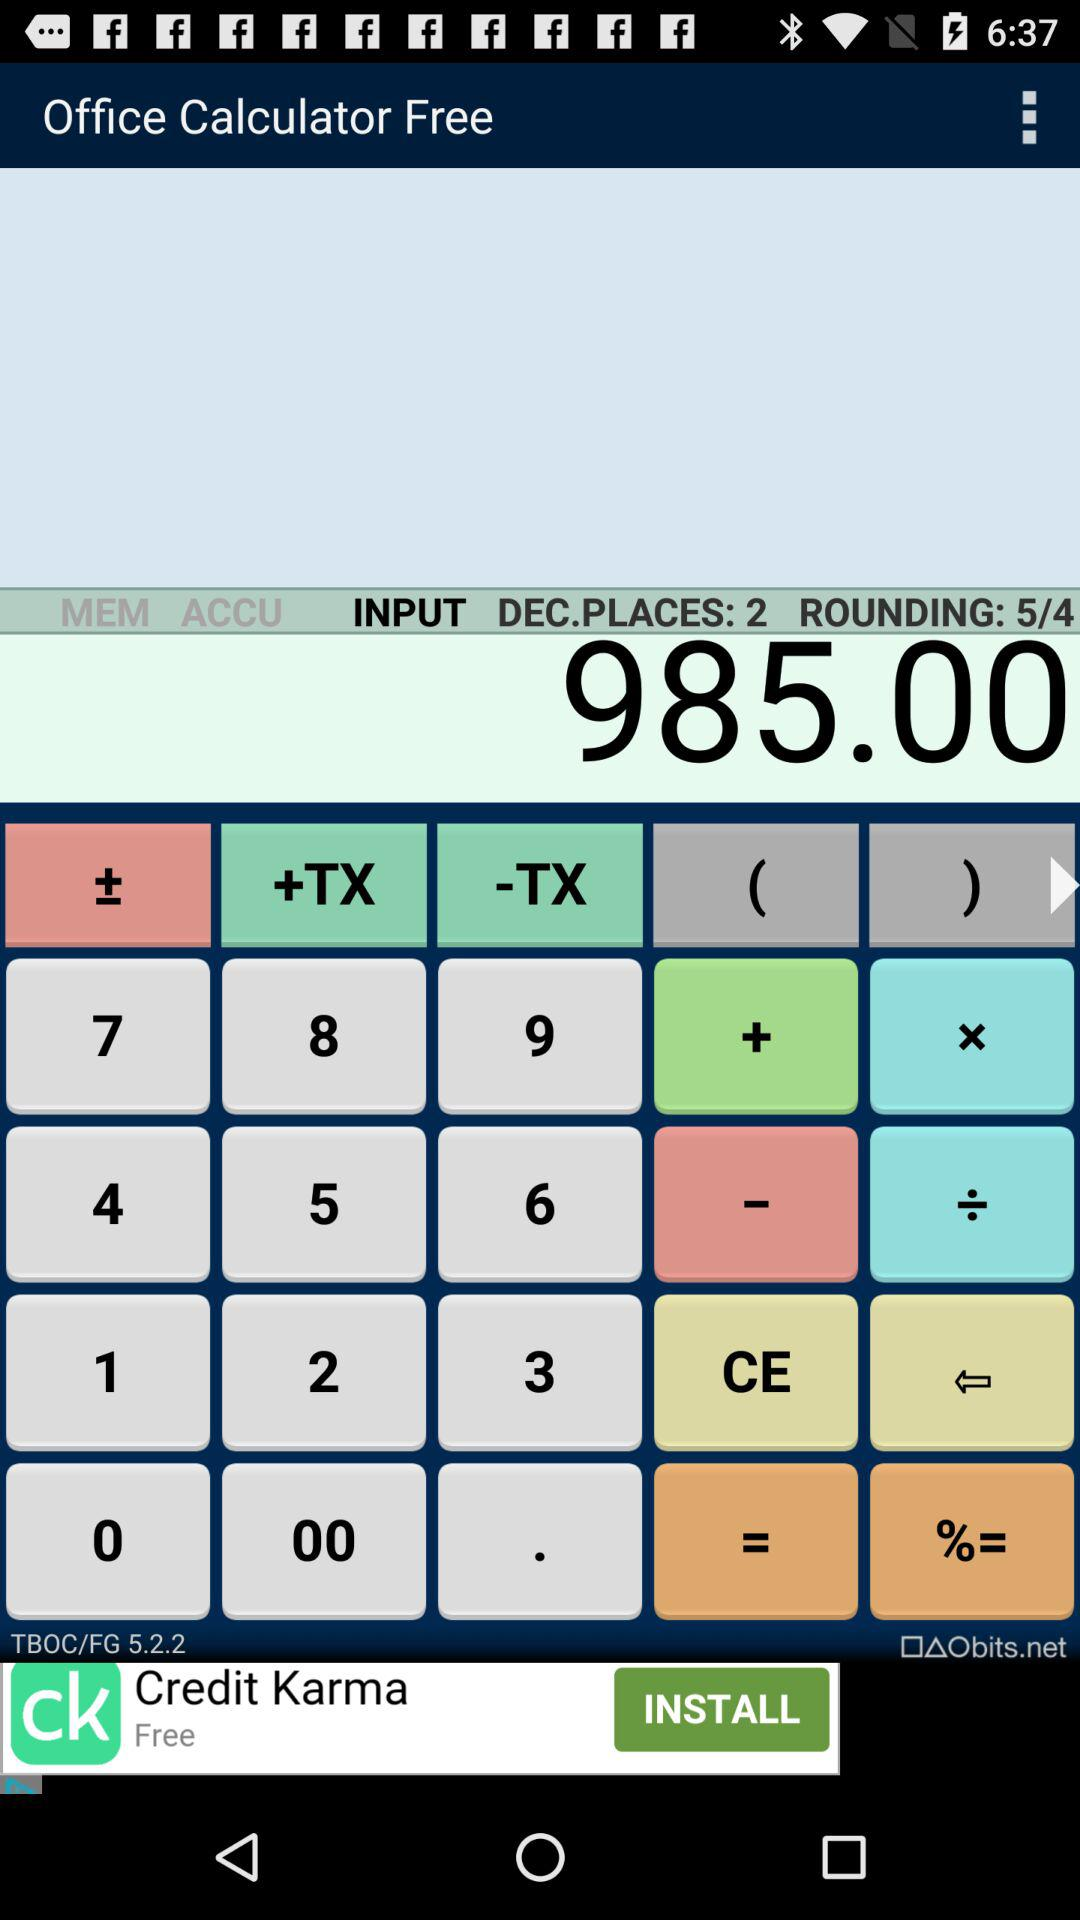How many decimal places are used by the calculator?
Answer the question using a single word or phrase. 2 